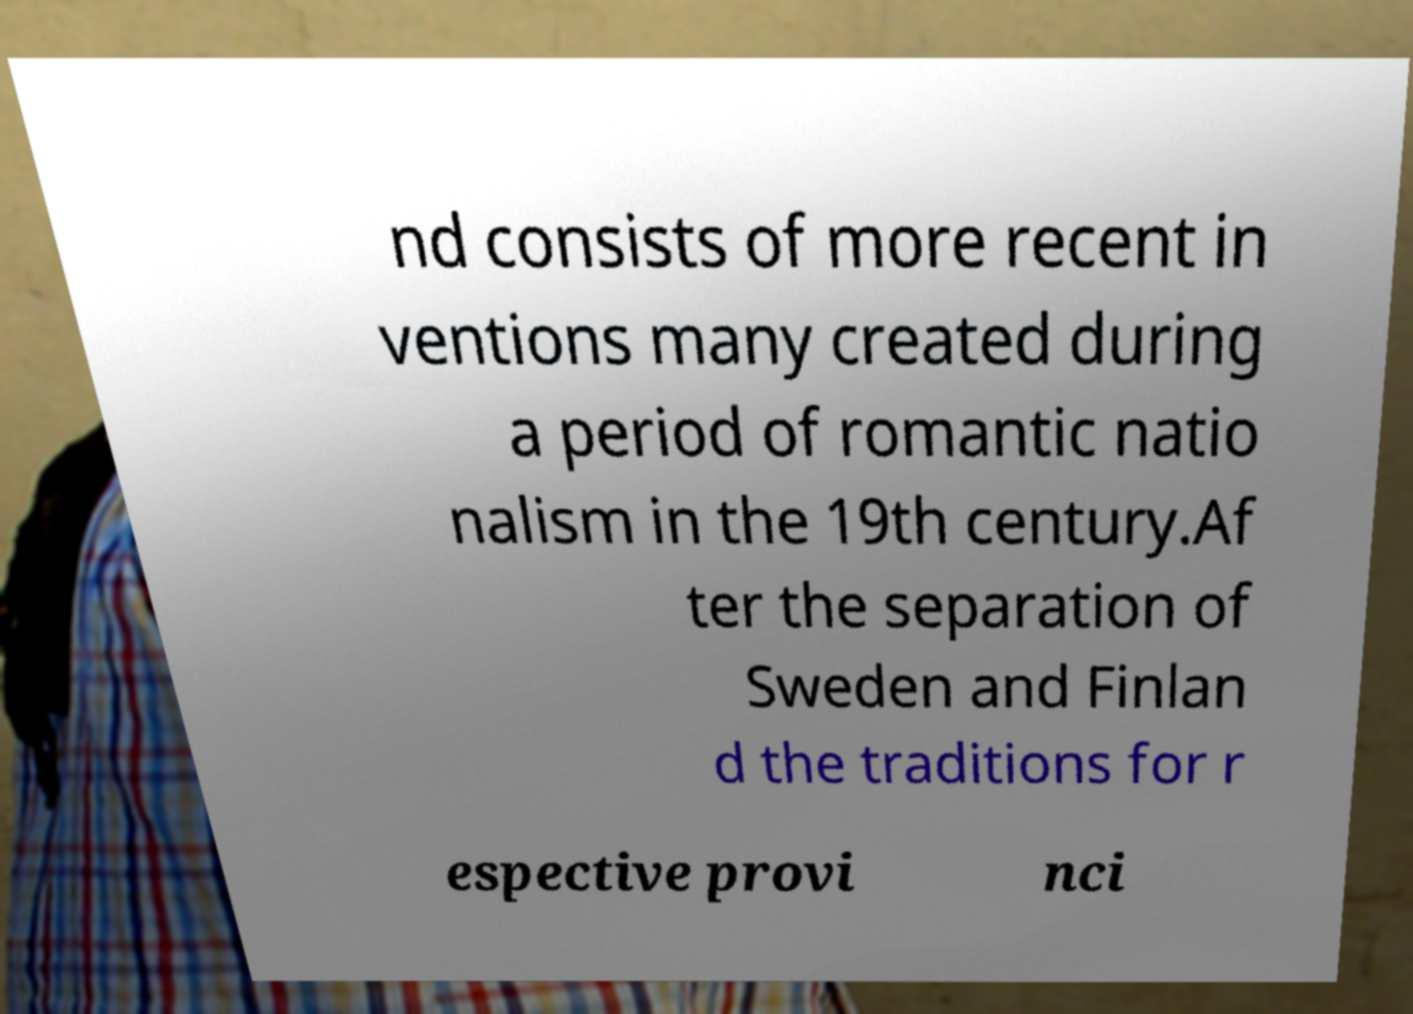For documentation purposes, I need the text within this image transcribed. Could you provide that? nd consists of more recent in ventions many created during a period of romantic natio nalism in the 19th century.Af ter the separation of Sweden and Finlan d the traditions for r espective provi nci 